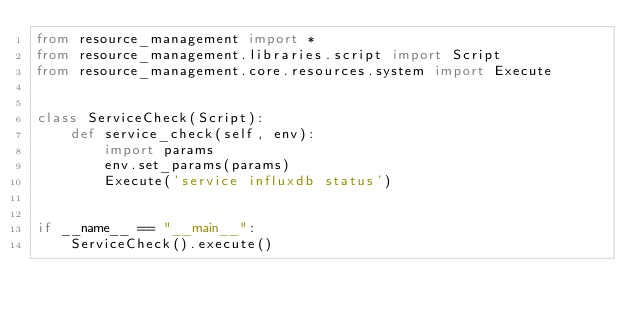<code> <loc_0><loc_0><loc_500><loc_500><_Python_>from resource_management import *
from resource_management.libraries.script import Script
from resource_management.core.resources.system import Execute


class ServiceCheck(Script):
    def service_check(self, env):
        import params
        env.set_params(params)
        Execute('service influxdb status')


if __name__ == "__main__":
    ServiceCheck().execute()
</code> 